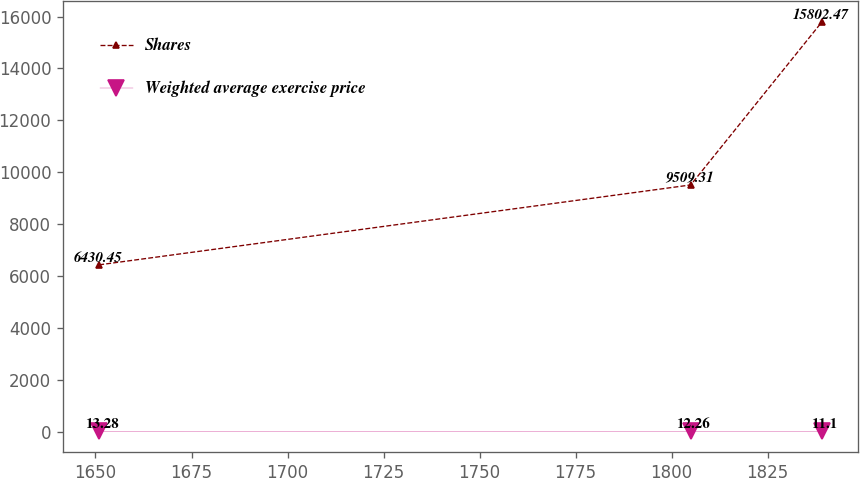Convert chart. <chart><loc_0><loc_0><loc_500><loc_500><line_chart><ecel><fcel>Shares<fcel>Weighted average exercise price<nl><fcel>1650.96<fcel>6430.45<fcel>13.28<nl><fcel>1804.98<fcel>9509.31<fcel>12.26<nl><fcel>1839.2<fcel>15802.5<fcel>11.1<nl></chart> 